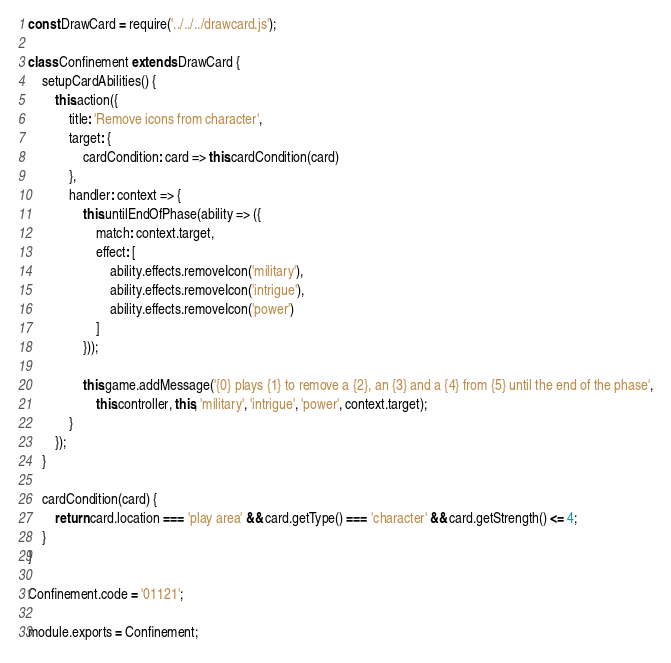Convert code to text. <code><loc_0><loc_0><loc_500><loc_500><_JavaScript_>const DrawCard = require('../../../drawcard.js');

class Confinement extends DrawCard {
    setupCardAbilities() {
        this.action({
            title: 'Remove icons from character',
            target: {
                cardCondition: card => this.cardCondition(card)
            },
            handler: context => {
                this.untilEndOfPhase(ability => ({
                    match: context.target,
                    effect: [
                        ability.effects.removeIcon('military'),
                        ability.effects.removeIcon('intrigue'),
                        ability.effects.removeIcon('power')
                    ]
                }));

                this.game.addMessage('{0} plays {1} to remove a {2}, an {3} and a {4} from {5} until the end of the phase',
                    this.controller, this, 'military', 'intrigue', 'power', context.target);
            }
        });
    }

    cardCondition(card) {
        return card.location === 'play area' && card.getType() === 'character' && card.getStrength() <= 4;
    }
}

Confinement.code = '01121';

module.exports = Confinement;
</code> 